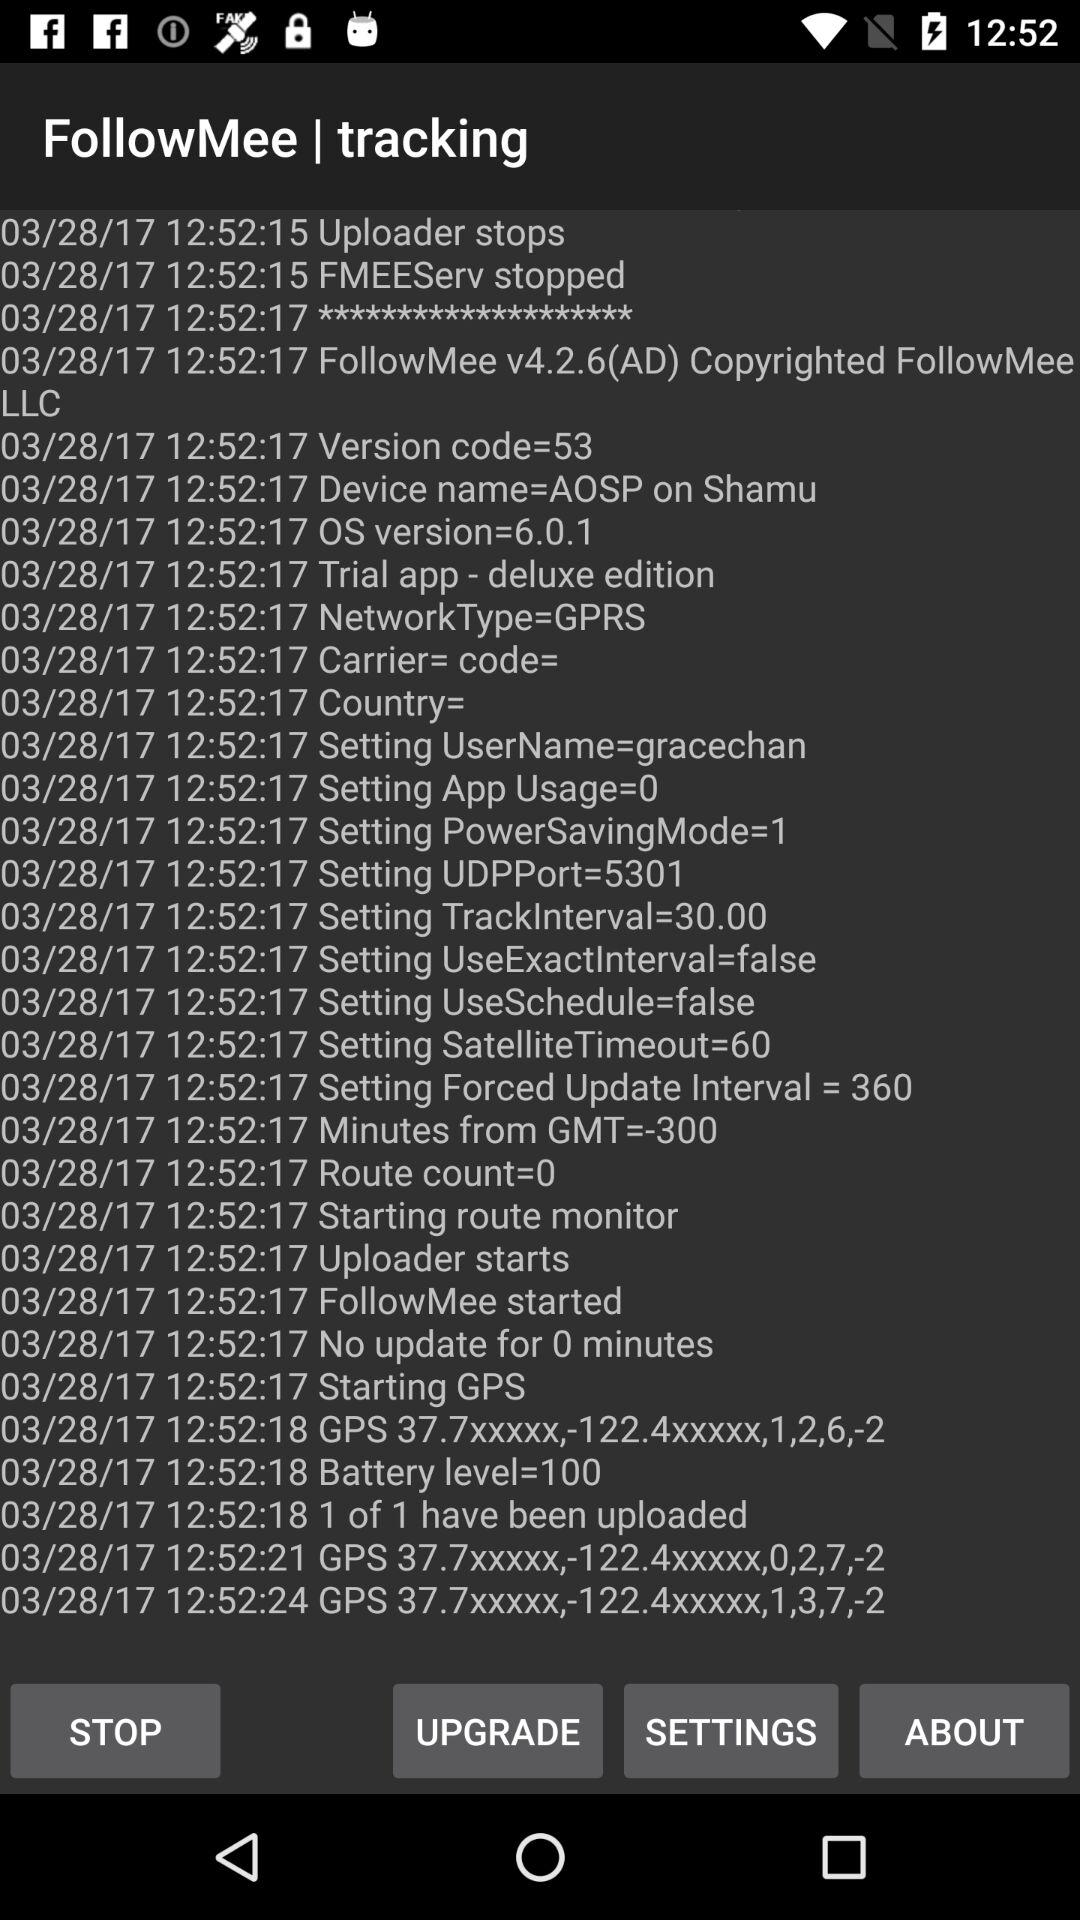How many minutes has it been since the last update?
Answer the question using a single word or phrase. 0 